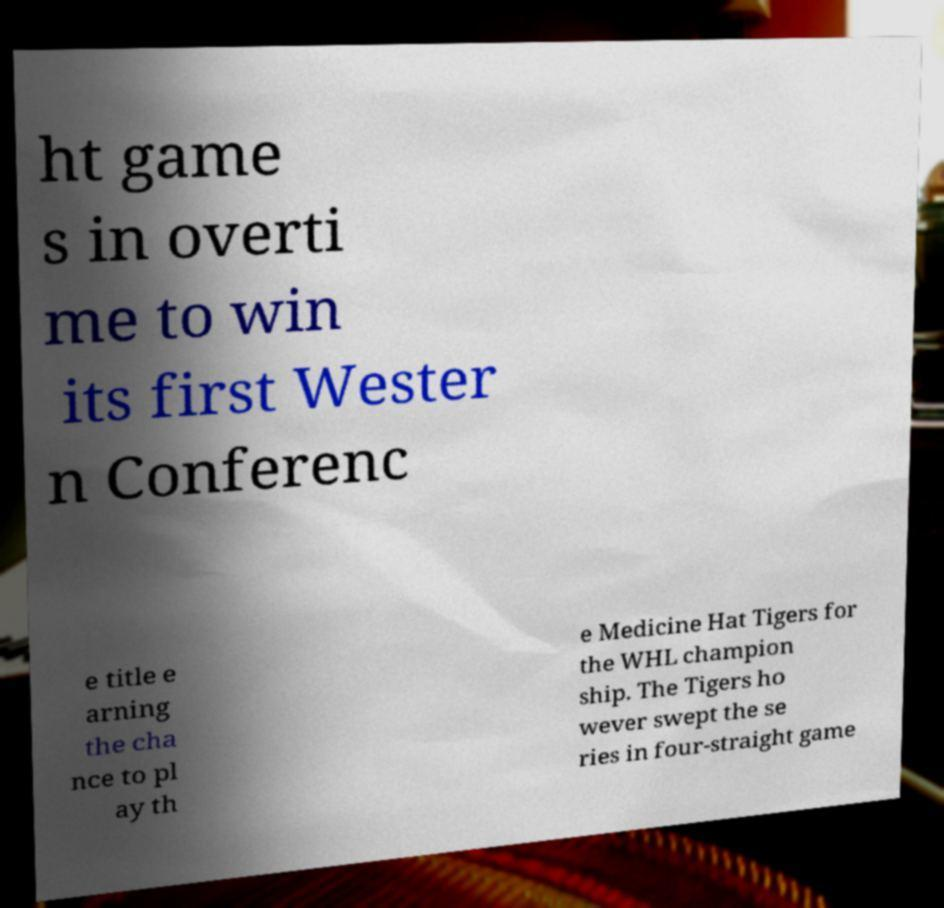Can you accurately transcribe the text from the provided image for me? ht game s in overti me to win its first Wester n Conferenc e title e arning the cha nce to pl ay th e Medicine Hat Tigers for the WHL champion ship. The Tigers ho wever swept the se ries in four-straight game 